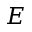Convert formula to latex. <formula><loc_0><loc_0><loc_500><loc_500>E</formula> 